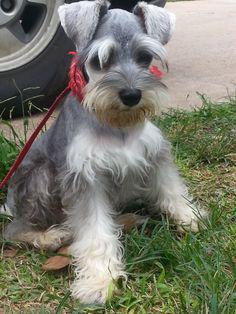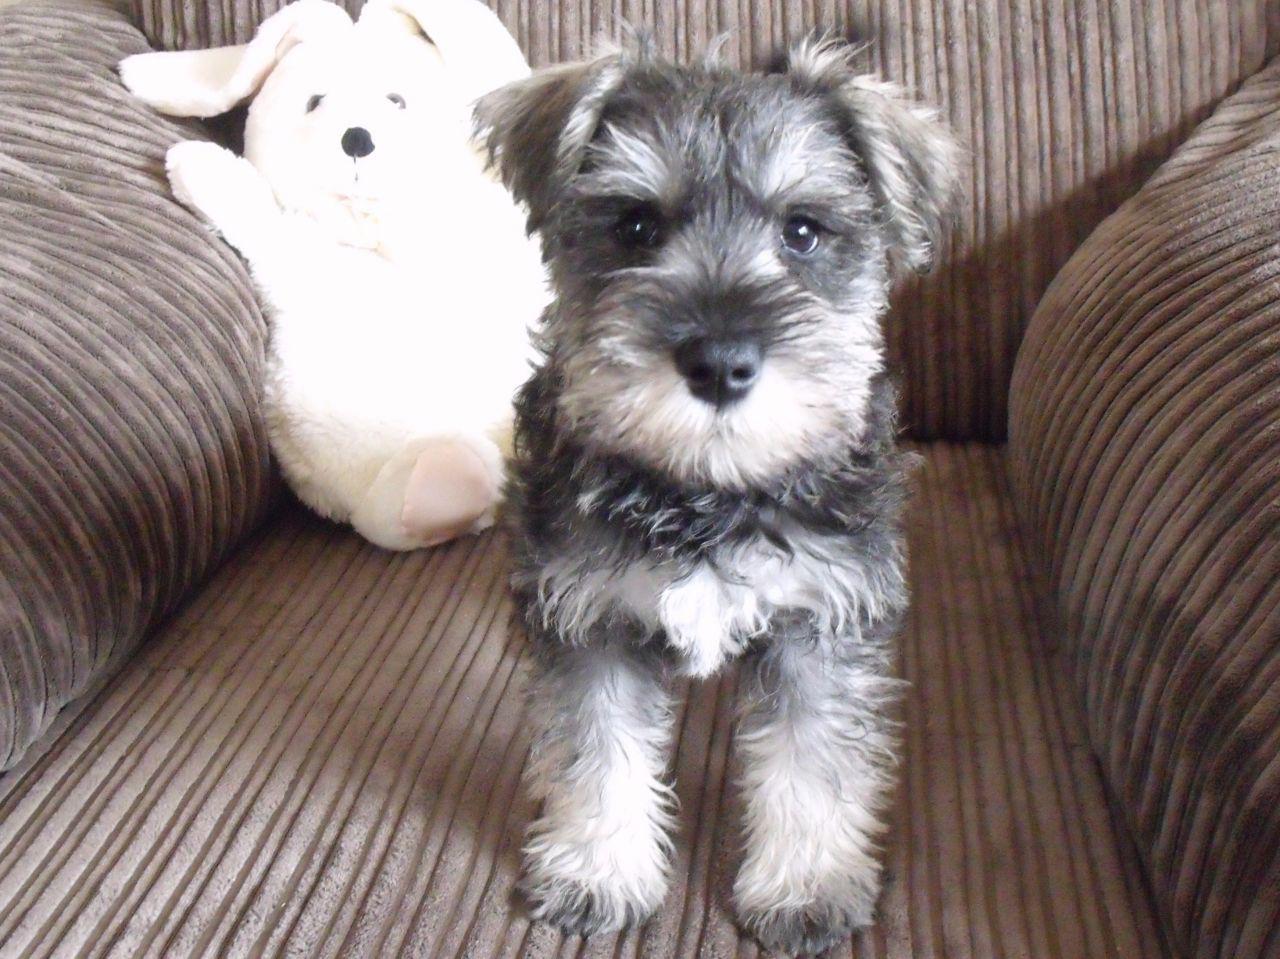The first image is the image on the left, the second image is the image on the right. Considering the images on both sides, is "The combined images contain five schnauzers, and at least four are sitting upright." valid? Answer yes or no. No. The first image is the image on the left, the second image is the image on the right. Given the left and right images, does the statement "The left image contains at least three dogs." hold true? Answer yes or no. No. 